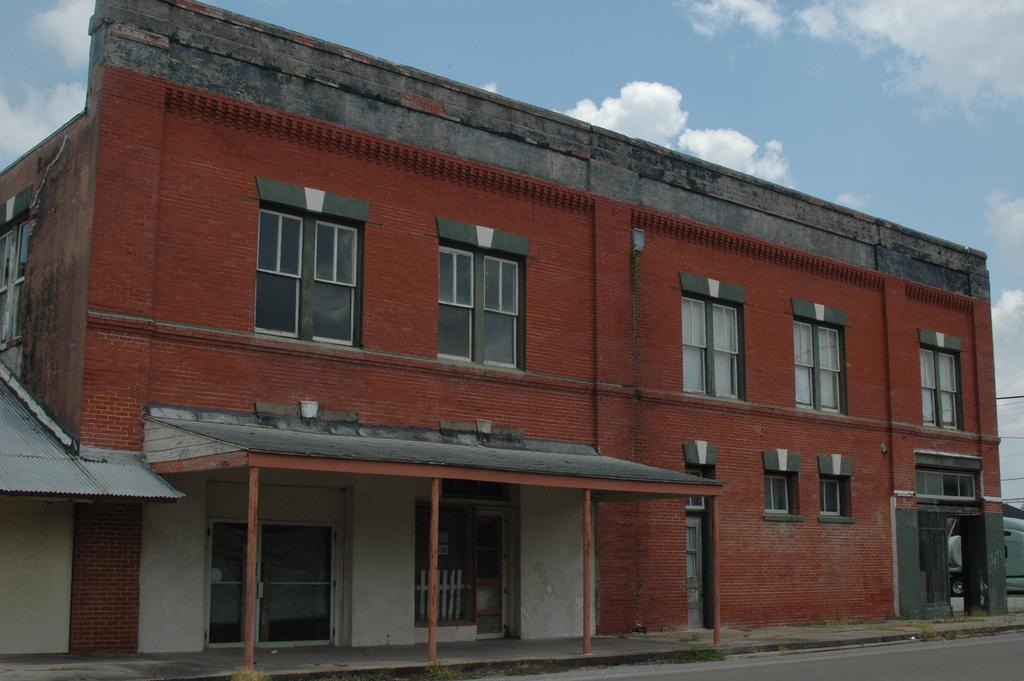What type of structure is visible in the image? There is a building in the image. What feature can be seen on the building? The building has windows. What else is present in the image besides the building? There are wires, poles, a vehicle, and the sky visible in the image. What is the condition of the sky in the image? The sky is visible in the background of the image, and clouds are present. Can you tell me how many zoo animals are visible in the image? There are no zoo animals present in the image. Is there an umbrella being used to pull the vehicle in the image? There is no umbrella or any indication of pulling the vehicle in the image. 